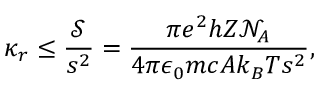Convert formula to latex. <formula><loc_0><loc_0><loc_500><loc_500>\kappa _ { r } \leq \frac { \ m a t h s c r { S } } { s ^ { 2 } } = \frac { \pi e ^ { 2 } h Z \mathcal { N } _ { A } } { 4 \pi \epsilon _ { 0 } m c A k _ { B } T s ^ { 2 } } ,</formula> 